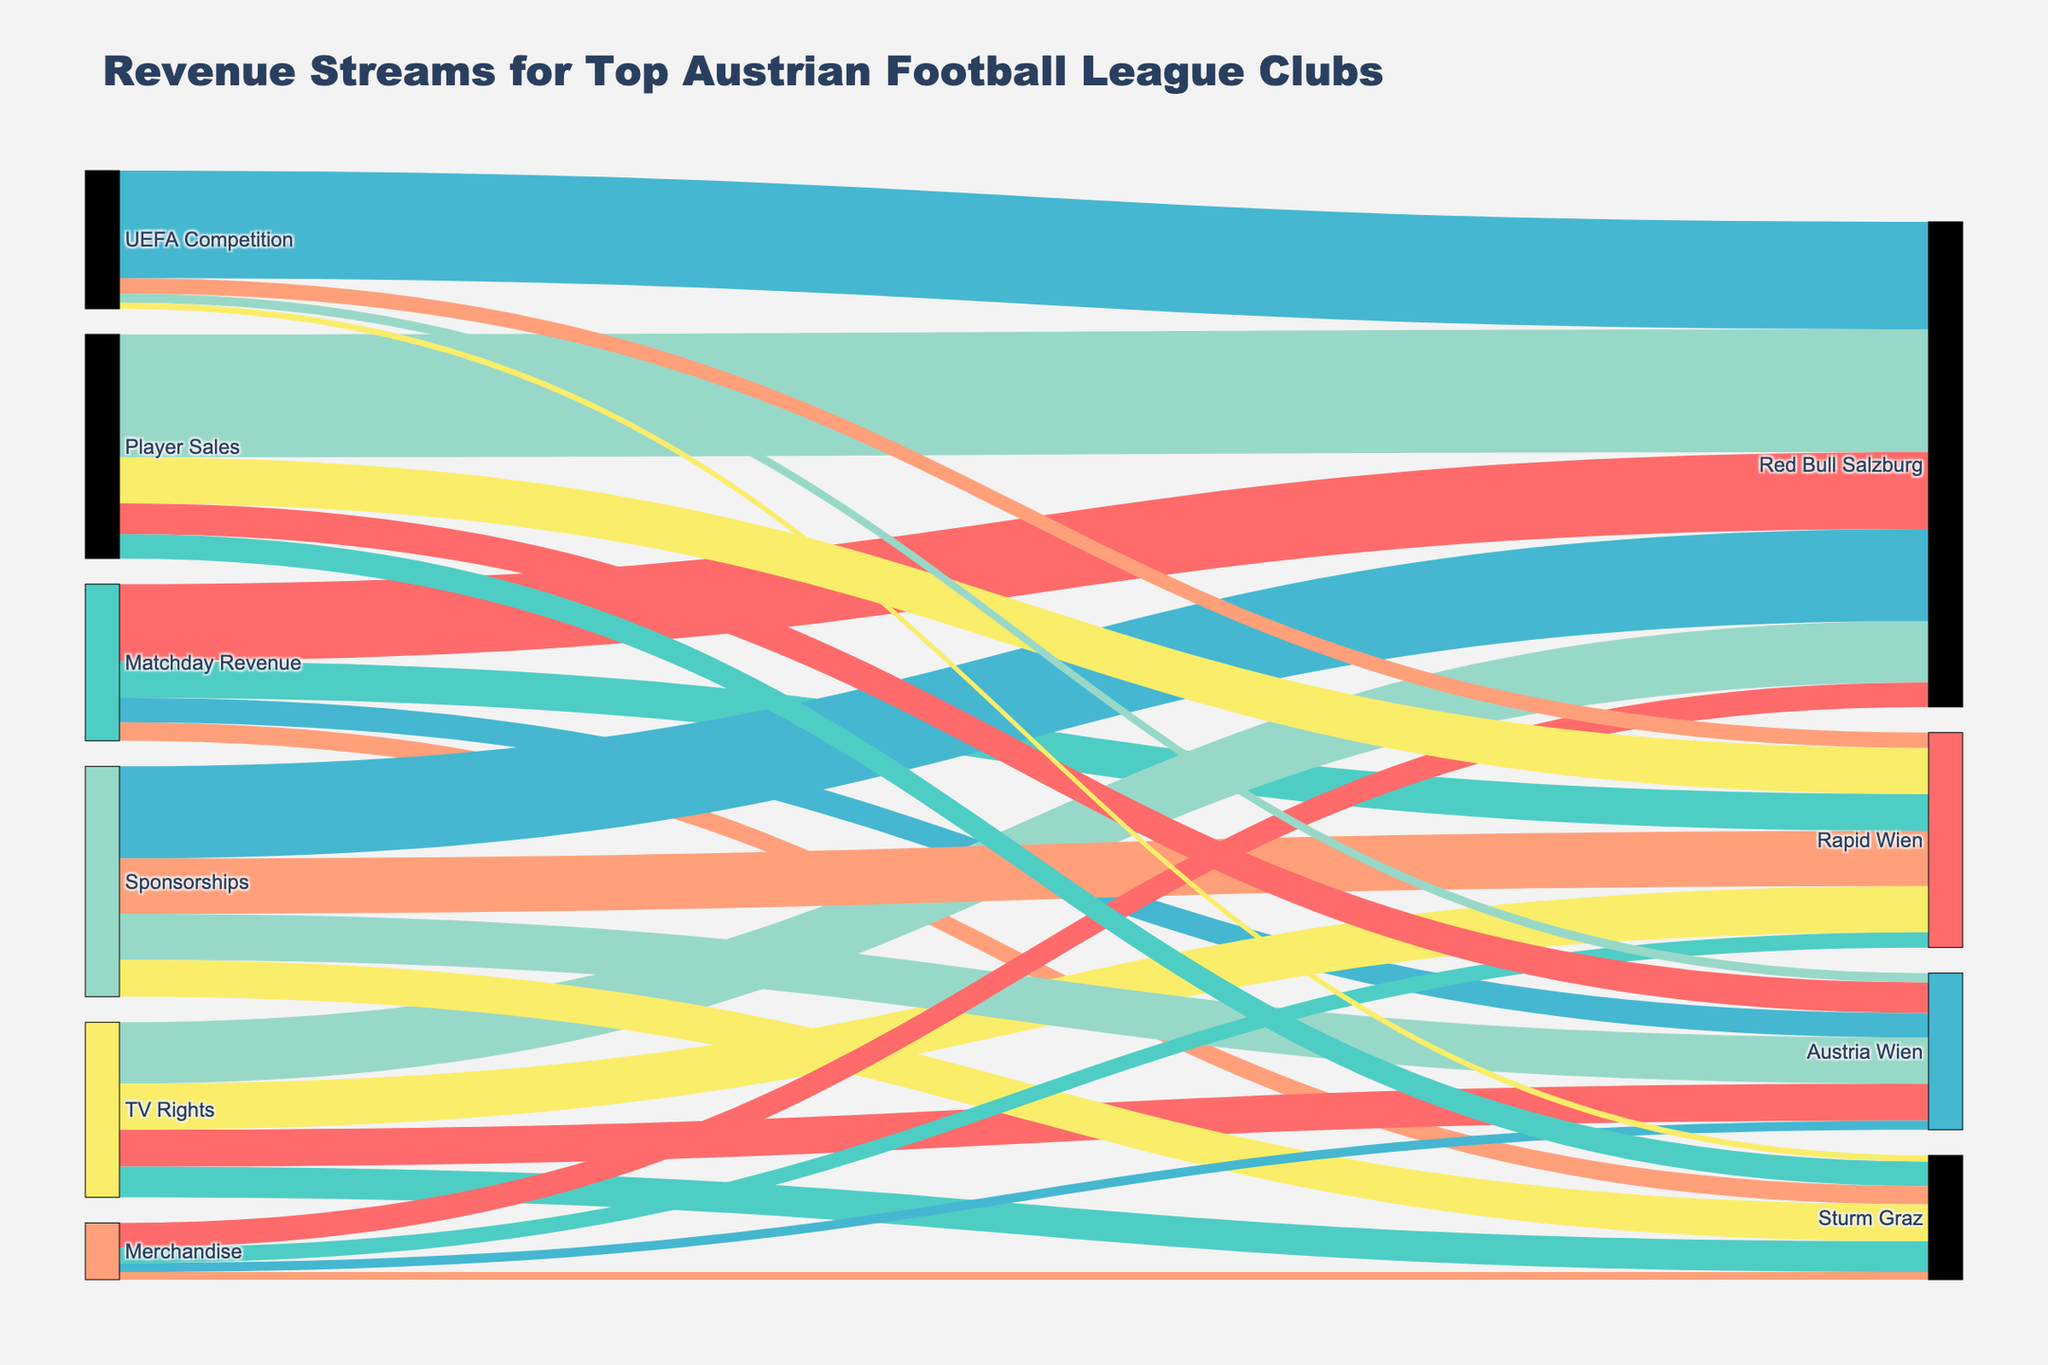Which club has the highest total revenue from all sources combined? To find the club with the highest total revenue, sum up the values for each club across all revenue sources: Red Bull Salzburg (25000000 + 20000000 + 30000000 + 8000000 + 40000000 + 35000000), Rapid Wien (12000000 + 15000000 + 18000000 + 5000000 + 15000000 + 5000000), Austria Wien (8000000 + 12000000 + 15000000 + 3000000 + 10000000 + 3000000), Sturm Graz (6000000 + 10000000 + 12000000 + 2500000 + 8000000 + 2000000). Red Bull Salzburg's total revenue is 158,000,000, which is the highest.
Answer: Red Bull Salzburg What is the smallest revenue stream for Austria Wien? To find this, look at all the revenue sources for Austria Wien and pick the smallest value: Matchday Revenue (8000000), TV Rights (12000000), Sponsorships (15000000), Merchandise (3000000), Player Sales (10000000), UEFA Competition (3000000). The smallest value is from Merchandise.
Answer: Merchandise How much more revenue does Red Bull Salzburg generate from Player Sales compared to Sturm Graz? Calculate the difference between revenue from Player Sales for Red Bull Salzburg and Sturm Graz: 40000000 (Red Bull Salzburg) - 8000000 (Sturm Graz) = 32000000.
Answer: 32000000 Which revenue stream contributes the most to the total revenue for Rapid Wien? Identify the revenue stream with the highest value for Rapid Wien: Matchday Revenue (12000000), TV Rights (15000000), Sponsorships (18000000), Merchandise (5000000), Player Sales (15000000), UEFA Competition (5000000). The highest value is from Sponsorships.
Answer: Sponsorships What is the combined revenue from TV Rights for all clubs? Sum the values for TV Rights across all clubs: Red Bull Salzburg (20000000) + Rapid Wien (15000000) + Austria Wien (12000000) + Sturm Graz (10000000) = 57000000.
Answer: 57000000 Which club earns the least from Merchandise sales? Compare the Merchandise revenue for all clubs: Red Bull Salzburg (8000000), Rapid Wien (5000000), Austria Wien (3000000), Sturm Graz (2500000). Sturm Graz has the lowest revenue from Merchandise sales.
Answer: Sturm Graz If you combine Matchday Revenue and Sponsorships for Austria Wien, is it more or less than the TV Rights revenue for Red Bull Salzburg? Calculate the combined revenue of Matchday Revenue and Sponsorships for Austria Wien: 8000000 + 15000000 = 23000000. Compare this with Red Bull Salzburg's TV Rights revenue which is 20000000. 23000000 is more than 20000000.
Answer: More Out of all the revenue sources, which one provides the highest single contribution to any club? Examine all individual revenue contributions for each club: The values are: Matchday Revenue (25000000), Player Sales (40000000), UEFA Competition (35000000). The highest single revenue contribution is from Player Sales for Red Bull Salzburg at 40000000.
Answer: Player Sales for Red Bull Salzburg 